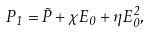Convert formula to latex. <formula><loc_0><loc_0><loc_500><loc_500>P _ { 1 } = \tilde { P } + \chi E _ { 0 } + \eta E _ { 0 } ^ { 2 } ,</formula> 